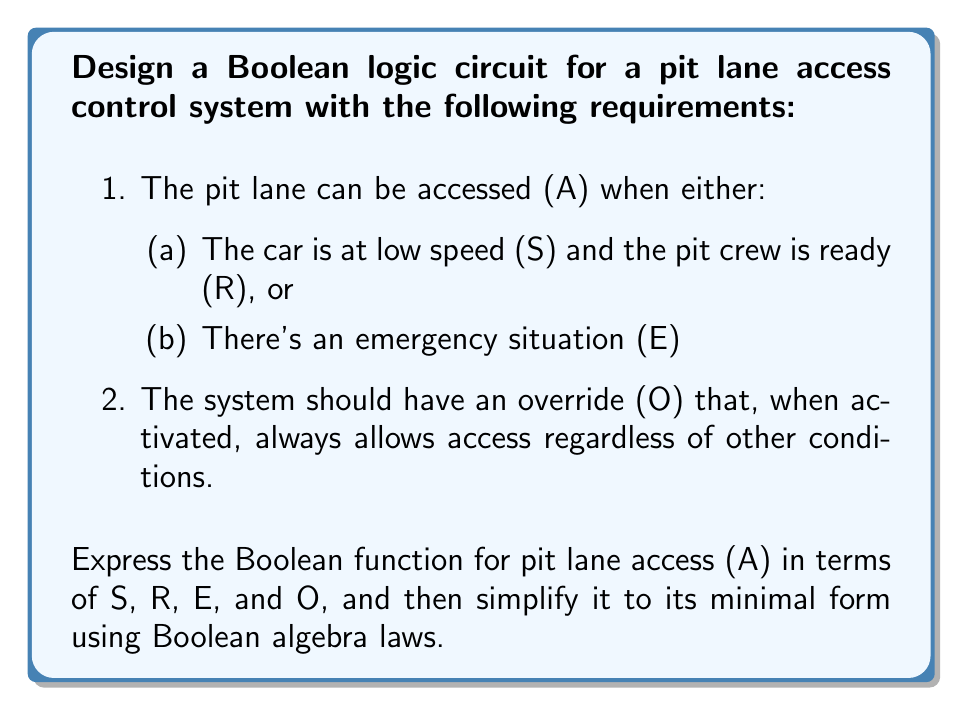Solve this math problem. Let's approach this step-by-step:

1) First, let's express the Boolean function based on the given conditions:

   $A = (S \cdot R + E) + O$

   This represents: Access is granted if [(low Speed AND crew Ready) OR Emergency] OR Override is active.

2) We can simplify this using Boolean algebra laws:

   $A = (S \cdot R + E) + O$
   $= S \cdot R + E + O$ (Associative law)

3) We can't simplify this further using Boolean algebra because:
   - $S$ and $R$ are not related to $E$ or $O$
   - $E$ and $O$ are independent variables

4) However, we can rearrange the terms for clarity:

   $A = O + E + (S \cdot R)$

This final form clearly shows that access is granted if any of these conditions are true:
- Override is active
- There's an Emergency
- The car is at low Speed AND the crew is Ready

This arrangement also prioritizes the override and emergency conditions, which aligns with safety protocols in motorsports.
Answer: $A = O + E + (S \cdot R)$ 